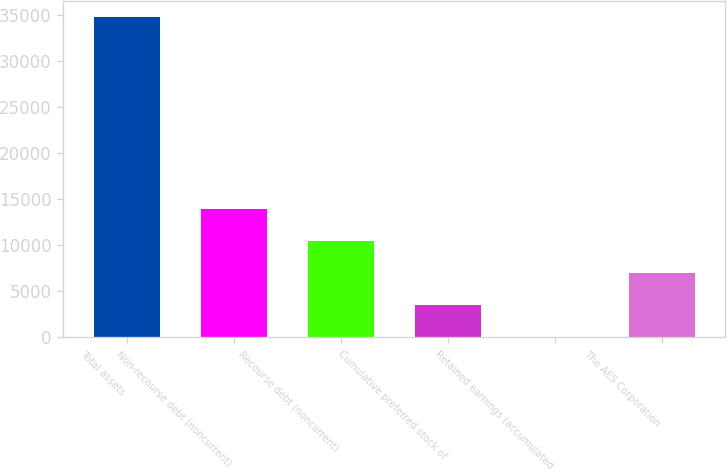Convert chart to OTSL. <chart><loc_0><loc_0><loc_500><loc_500><bar_chart><fcel>Total assets<fcel>Non-recourse debt (noncurrent)<fcel>Recourse debt (noncurrent)<fcel>Cumulative preferred stock of<fcel>Retained earnings (accumulated<fcel>The AES Corporation<nl><fcel>34806<fcel>13927.2<fcel>10447.4<fcel>3487.8<fcel>8<fcel>6967.6<nl></chart> 